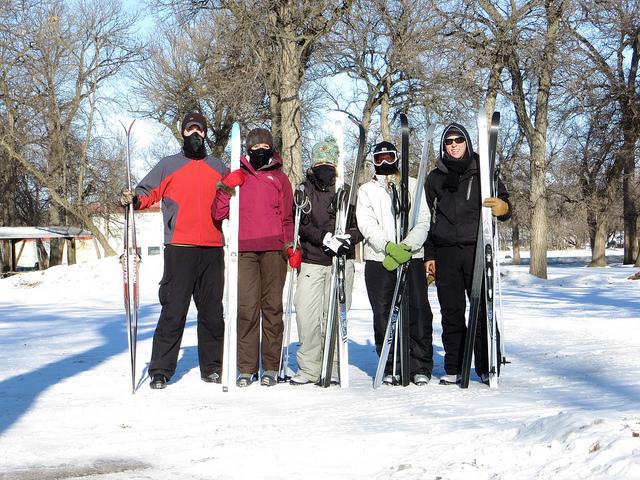Is the person in the middle missing a face?
Write a very short answer. No. Are these bank robbers?
Write a very short answer. No. Are they going to ski?
Answer briefly. Yes. 